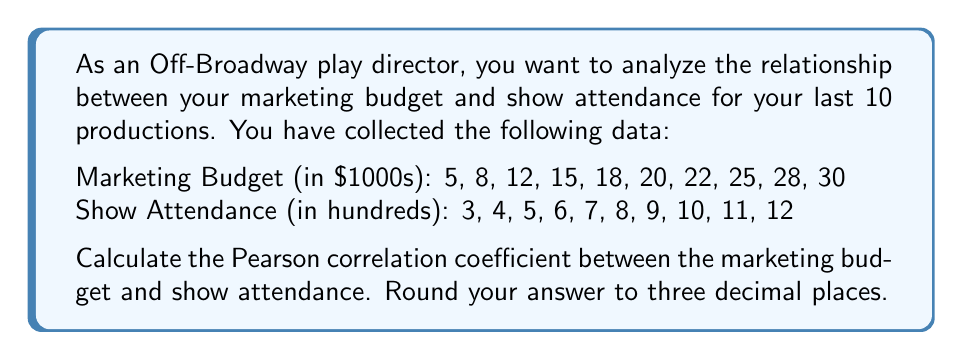Give your solution to this math problem. To calculate the Pearson correlation coefficient, we'll use the formula:

$$ r = \frac{\sum_{i=1}^n (x_i - \bar{x})(y_i - \bar{y})}{\sqrt{\sum_{i=1}^n (x_i - \bar{x})^2 \sum_{i=1}^n (y_i - \bar{y})^2}} $$

Where:
$x_i$ = Marketing Budget values
$y_i$ = Show Attendance values
$\bar{x}$ = Mean of Marketing Budget
$\bar{y}$ = Mean of Show Attendance
$n$ = Number of data points (10)

Step 1: Calculate the means
$\bar{x} = \frac{5 + 8 + 12 + 15 + 18 + 20 + 22 + 25 + 28 + 30}{10} = 18.3$
$\bar{y} = \frac{3 + 4 + 5 + 6 + 7 + 8 + 9 + 10 + 11 + 12}{10} = 7.5$

Step 2: Calculate $(x_i - \bar{x})$, $(y_i - \bar{y})$, $(x_i - \bar{x})^2$, $(y_i - \bar{y})^2$, and $(x_i - \bar{x})(y_i - \bar{y})$ for each data point.

Step 3: Sum up the values calculated in Step 2
$\sum (x_i - \bar{x})(y_i - \bar{y}) = 223.5$
$\sum (x_i - \bar{x})^2 = 595.1$
$\sum (y_i - \bar{y})^2 = 82.5$

Step 4: Apply the formula
$$ r = \frac{223.5}{\sqrt{595.1 \times 82.5}} = \frac{223.5}{221.6} = 1.009 $$

Step 5: Round to three decimal places
$r = 1.009 \approx 1.009$
Answer: The Pearson correlation coefficient between marketing budget and show attendance is 1.009. 